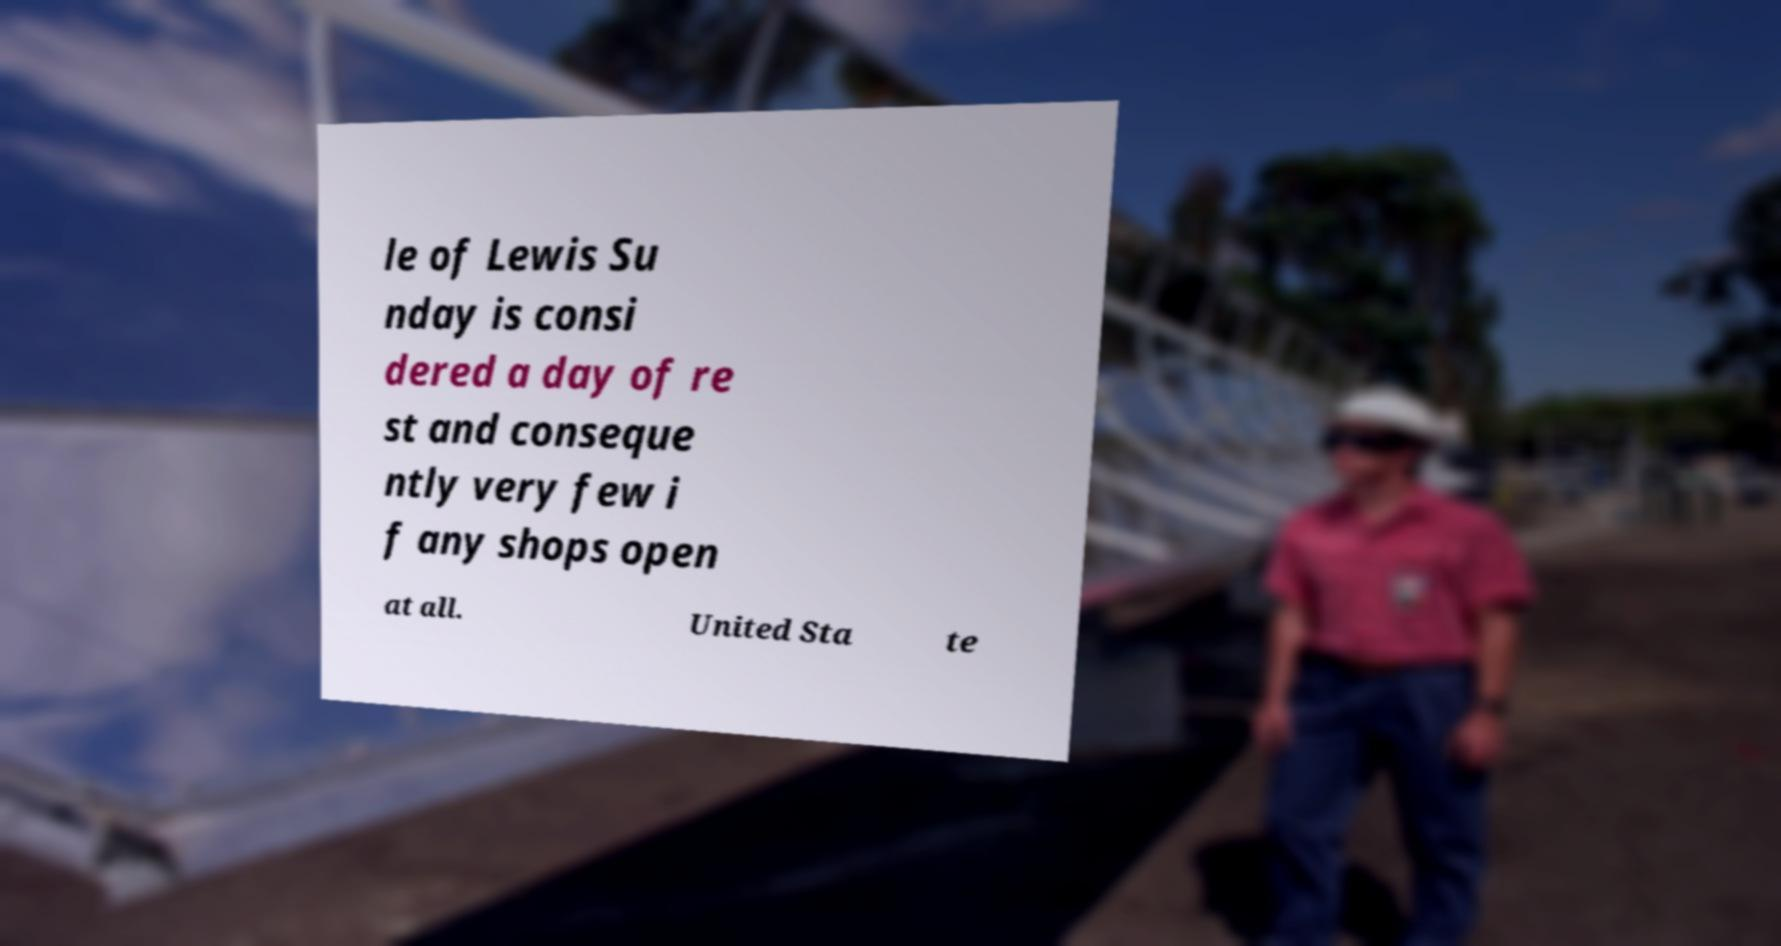Please read and relay the text visible in this image. What does it say? le of Lewis Su nday is consi dered a day of re st and conseque ntly very few i f any shops open at all. United Sta te 